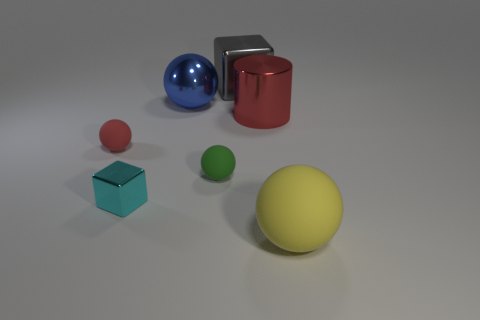What is the shape of the thing that is behind the large sphere behind the yellow rubber sphere?
Offer a very short reply. Cube. The small matte object in front of the small sphere on the left side of the large metal thing to the left of the large gray shiny object is what shape?
Make the answer very short. Sphere. What number of other yellow rubber things have the same shape as the yellow thing?
Make the answer very short. 0. There is a small rubber ball that is left of the large metal ball; what number of big blue metallic balls are on the left side of it?
Offer a terse response. 0. How many matte objects are big blue things or large spheres?
Your answer should be very brief. 1. Are there any purple cubes made of the same material as the big red object?
Provide a succinct answer. No. What number of objects are either matte objects that are behind the big yellow ball or cyan things that are to the left of the big metal block?
Your answer should be compact. 3. There is a large ball that is behind the yellow thing; is its color the same as the large matte thing?
Offer a very short reply. No. How many other objects are the same color as the big metal cylinder?
Your response must be concise. 1. What is the material of the big yellow sphere?
Your answer should be compact. Rubber. 